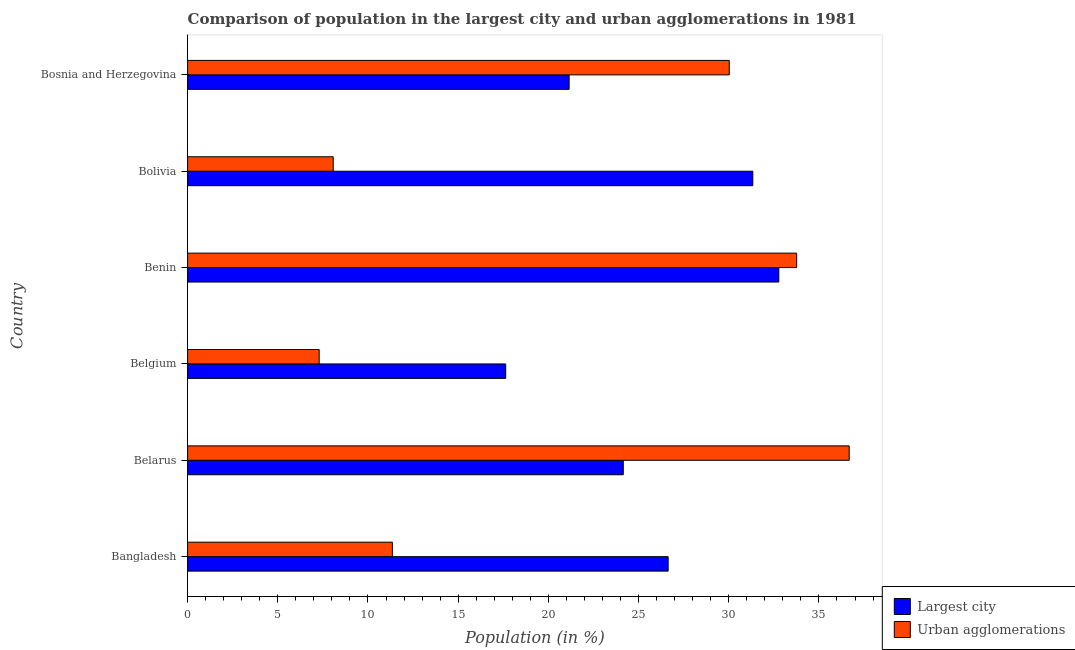How many different coloured bars are there?
Your answer should be very brief. 2. What is the label of the 1st group of bars from the top?
Your response must be concise. Bosnia and Herzegovina. What is the population in the largest city in Bosnia and Herzegovina?
Give a very brief answer. 21.15. Across all countries, what is the maximum population in the largest city?
Offer a terse response. 32.78. Across all countries, what is the minimum population in urban agglomerations?
Make the answer very short. 7.3. In which country was the population in urban agglomerations maximum?
Give a very brief answer. Belarus. In which country was the population in the largest city minimum?
Provide a short and direct response. Belgium. What is the total population in the largest city in the graph?
Ensure brevity in your answer.  153.69. What is the difference between the population in urban agglomerations in Bangladesh and that in Belgium?
Offer a terse response. 4.06. What is the difference between the population in the largest city in Bosnia and Herzegovina and the population in urban agglomerations in Belgium?
Make the answer very short. 13.86. What is the average population in urban agglomerations per country?
Offer a very short reply. 21.2. What is the difference between the highest and the second highest population in urban agglomerations?
Make the answer very short. 2.91. What is the difference between the highest and the lowest population in urban agglomerations?
Offer a very short reply. 29.38. In how many countries, is the population in the largest city greater than the average population in the largest city taken over all countries?
Keep it short and to the point. 3. Is the sum of the population in the largest city in Benin and Bolivia greater than the maximum population in urban agglomerations across all countries?
Your response must be concise. Yes. What does the 2nd bar from the top in Belarus represents?
Give a very brief answer. Largest city. What does the 2nd bar from the bottom in Benin represents?
Your answer should be compact. Urban agglomerations. Are the values on the major ticks of X-axis written in scientific E-notation?
Your answer should be very brief. No. What is the title of the graph?
Your response must be concise. Comparison of population in the largest city and urban agglomerations in 1981. Does "Electricity" appear as one of the legend labels in the graph?
Your answer should be compact. No. What is the label or title of the Y-axis?
Your answer should be very brief. Country. What is the Population (in %) in Largest city in Bangladesh?
Your answer should be very brief. 26.64. What is the Population (in %) of Urban agglomerations in Bangladesh?
Offer a terse response. 11.35. What is the Population (in %) in Largest city in Belarus?
Ensure brevity in your answer.  24.15. What is the Population (in %) in Urban agglomerations in Belarus?
Keep it short and to the point. 36.68. What is the Population (in %) in Largest city in Belgium?
Give a very brief answer. 17.63. What is the Population (in %) of Urban agglomerations in Belgium?
Make the answer very short. 7.3. What is the Population (in %) of Largest city in Benin?
Give a very brief answer. 32.78. What is the Population (in %) in Urban agglomerations in Benin?
Your answer should be compact. 33.76. What is the Population (in %) in Largest city in Bolivia?
Provide a short and direct response. 31.33. What is the Population (in %) in Urban agglomerations in Bolivia?
Provide a succinct answer. 8.07. What is the Population (in %) in Largest city in Bosnia and Herzegovina?
Your answer should be very brief. 21.15. What is the Population (in %) in Urban agglomerations in Bosnia and Herzegovina?
Your response must be concise. 30.03. Across all countries, what is the maximum Population (in %) of Largest city?
Ensure brevity in your answer.  32.78. Across all countries, what is the maximum Population (in %) in Urban agglomerations?
Offer a terse response. 36.68. Across all countries, what is the minimum Population (in %) in Largest city?
Your answer should be very brief. 17.63. Across all countries, what is the minimum Population (in %) in Urban agglomerations?
Your response must be concise. 7.3. What is the total Population (in %) in Largest city in the graph?
Your answer should be very brief. 153.69. What is the total Population (in %) in Urban agglomerations in the graph?
Your answer should be compact. 127.19. What is the difference between the Population (in %) in Largest city in Bangladesh and that in Belarus?
Provide a succinct answer. 2.49. What is the difference between the Population (in %) of Urban agglomerations in Bangladesh and that in Belarus?
Make the answer very short. -25.33. What is the difference between the Population (in %) in Largest city in Bangladesh and that in Belgium?
Your answer should be compact. 9.01. What is the difference between the Population (in %) in Urban agglomerations in Bangladesh and that in Belgium?
Your answer should be very brief. 4.06. What is the difference between the Population (in %) of Largest city in Bangladesh and that in Benin?
Offer a terse response. -6.13. What is the difference between the Population (in %) in Urban agglomerations in Bangladesh and that in Benin?
Provide a short and direct response. -22.41. What is the difference between the Population (in %) in Largest city in Bangladesh and that in Bolivia?
Your answer should be compact. -4.69. What is the difference between the Population (in %) in Urban agglomerations in Bangladesh and that in Bolivia?
Ensure brevity in your answer.  3.28. What is the difference between the Population (in %) in Largest city in Bangladesh and that in Bosnia and Herzegovina?
Ensure brevity in your answer.  5.49. What is the difference between the Population (in %) in Urban agglomerations in Bangladesh and that in Bosnia and Herzegovina?
Keep it short and to the point. -18.68. What is the difference between the Population (in %) in Largest city in Belarus and that in Belgium?
Your answer should be compact. 6.52. What is the difference between the Population (in %) in Urban agglomerations in Belarus and that in Belgium?
Your answer should be very brief. 29.38. What is the difference between the Population (in %) of Largest city in Belarus and that in Benin?
Your answer should be compact. -8.62. What is the difference between the Population (in %) in Urban agglomerations in Belarus and that in Benin?
Offer a terse response. 2.91. What is the difference between the Population (in %) of Largest city in Belarus and that in Bolivia?
Ensure brevity in your answer.  -7.18. What is the difference between the Population (in %) in Urban agglomerations in Belarus and that in Bolivia?
Offer a very short reply. 28.61. What is the difference between the Population (in %) of Largest city in Belarus and that in Bosnia and Herzegovina?
Your answer should be compact. 3. What is the difference between the Population (in %) of Urban agglomerations in Belarus and that in Bosnia and Herzegovina?
Your response must be concise. 6.65. What is the difference between the Population (in %) in Largest city in Belgium and that in Benin?
Your answer should be compact. -15.14. What is the difference between the Population (in %) of Urban agglomerations in Belgium and that in Benin?
Offer a terse response. -26.47. What is the difference between the Population (in %) of Largest city in Belgium and that in Bolivia?
Offer a terse response. -13.7. What is the difference between the Population (in %) in Urban agglomerations in Belgium and that in Bolivia?
Offer a terse response. -0.78. What is the difference between the Population (in %) of Largest city in Belgium and that in Bosnia and Herzegovina?
Make the answer very short. -3.52. What is the difference between the Population (in %) in Urban agglomerations in Belgium and that in Bosnia and Herzegovina?
Your answer should be very brief. -22.73. What is the difference between the Population (in %) in Largest city in Benin and that in Bolivia?
Make the answer very short. 1.44. What is the difference between the Population (in %) of Urban agglomerations in Benin and that in Bolivia?
Your answer should be very brief. 25.69. What is the difference between the Population (in %) in Largest city in Benin and that in Bosnia and Herzegovina?
Provide a succinct answer. 11.62. What is the difference between the Population (in %) of Urban agglomerations in Benin and that in Bosnia and Herzegovina?
Offer a terse response. 3.74. What is the difference between the Population (in %) in Largest city in Bolivia and that in Bosnia and Herzegovina?
Give a very brief answer. 10.18. What is the difference between the Population (in %) in Urban agglomerations in Bolivia and that in Bosnia and Herzegovina?
Provide a succinct answer. -21.96. What is the difference between the Population (in %) in Largest city in Bangladesh and the Population (in %) in Urban agglomerations in Belarus?
Offer a very short reply. -10.04. What is the difference between the Population (in %) in Largest city in Bangladesh and the Population (in %) in Urban agglomerations in Belgium?
Keep it short and to the point. 19.35. What is the difference between the Population (in %) of Largest city in Bangladesh and the Population (in %) of Urban agglomerations in Benin?
Your answer should be compact. -7.12. What is the difference between the Population (in %) of Largest city in Bangladesh and the Population (in %) of Urban agglomerations in Bolivia?
Give a very brief answer. 18.57. What is the difference between the Population (in %) in Largest city in Bangladesh and the Population (in %) in Urban agglomerations in Bosnia and Herzegovina?
Offer a very short reply. -3.39. What is the difference between the Population (in %) of Largest city in Belarus and the Population (in %) of Urban agglomerations in Belgium?
Your answer should be compact. 16.86. What is the difference between the Population (in %) in Largest city in Belarus and the Population (in %) in Urban agglomerations in Benin?
Keep it short and to the point. -9.61. What is the difference between the Population (in %) of Largest city in Belarus and the Population (in %) of Urban agglomerations in Bolivia?
Make the answer very short. 16.08. What is the difference between the Population (in %) in Largest city in Belarus and the Population (in %) in Urban agglomerations in Bosnia and Herzegovina?
Provide a succinct answer. -5.88. What is the difference between the Population (in %) in Largest city in Belgium and the Population (in %) in Urban agglomerations in Benin?
Give a very brief answer. -16.13. What is the difference between the Population (in %) of Largest city in Belgium and the Population (in %) of Urban agglomerations in Bolivia?
Keep it short and to the point. 9.56. What is the difference between the Population (in %) of Largest city in Belgium and the Population (in %) of Urban agglomerations in Bosnia and Herzegovina?
Make the answer very short. -12.39. What is the difference between the Population (in %) in Largest city in Benin and the Population (in %) in Urban agglomerations in Bolivia?
Your answer should be compact. 24.7. What is the difference between the Population (in %) in Largest city in Benin and the Population (in %) in Urban agglomerations in Bosnia and Herzegovina?
Give a very brief answer. 2.75. What is the difference between the Population (in %) in Largest city in Bolivia and the Population (in %) in Urban agglomerations in Bosnia and Herzegovina?
Your answer should be very brief. 1.31. What is the average Population (in %) of Largest city per country?
Your answer should be very brief. 25.61. What is the average Population (in %) in Urban agglomerations per country?
Make the answer very short. 21.2. What is the difference between the Population (in %) in Largest city and Population (in %) in Urban agglomerations in Bangladesh?
Your answer should be compact. 15.29. What is the difference between the Population (in %) in Largest city and Population (in %) in Urban agglomerations in Belarus?
Your answer should be compact. -12.53. What is the difference between the Population (in %) of Largest city and Population (in %) of Urban agglomerations in Belgium?
Provide a succinct answer. 10.34. What is the difference between the Population (in %) in Largest city and Population (in %) in Urban agglomerations in Benin?
Offer a very short reply. -0.99. What is the difference between the Population (in %) in Largest city and Population (in %) in Urban agglomerations in Bolivia?
Offer a very short reply. 23.26. What is the difference between the Population (in %) in Largest city and Population (in %) in Urban agglomerations in Bosnia and Herzegovina?
Keep it short and to the point. -8.88. What is the ratio of the Population (in %) in Largest city in Bangladesh to that in Belarus?
Provide a short and direct response. 1.1. What is the ratio of the Population (in %) of Urban agglomerations in Bangladesh to that in Belarus?
Your answer should be very brief. 0.31. What is the ratio of the Population (in %) in Largest city in Bangladesh to that in Belgium?
Your answer should be very brief. 1.51. What is the ratio of the Population (in %) of Urban agglomerations in Bangladesh to that in Belgium?
Your answer should be very brief. 1.56. What is the ratio of the Population (in %) of Largest city in Bangladesh to that in Benin?
Give a very brief answer. 0.81. What is the ratio of the Population (in %) in Urban agglomerations in Bangladesh to that in Benin?
Your answer should be compact. 0.34. What is the ratio of the Population (in %) in Largest city in Bangladesh to that in Bolivia?
Provide a succinct answer. 0.85. What is the ratio of the Population (in %) of Urban agglomerations in Bangladesh to that in Bolivia?
Your response must be concise. 1.41. What is the ratio of the Population (in %) in Largest city in Bangladesh to that in Bosnia and Herzegovina?
Make the answer very short. 1.26. What is the ratio of the Population (in %) of Urban agglomerations in Bangladesh to that in Bosnia and Herzegovina?
Provide a short and direct response. 0.38. What is the ratio of the Population (in %) of Largest city in Belarus to that in Belgium?
Make the answer very short. 1.37. What is the ratio of the Population (in %) of Urban agglomerations in Belarus to that in Belgium?
Ensure brevity in your answer.  5.03. What is the ratio of the Population (in %) of Largest city in Belarus to that in Benin?
Ensure brevity in your answer.  0.74. What is the ratio of the Population (in %) in Urban agglomerations in Belarus to that in Benin?
Provide a succinct answer. 1.09. What is the ratio of the Population (in %) of Largest city in Belarus to that in Bolivia?
Offer a terse response. 0.77. What is the ratio of the Population (in %) in Urban agglomerations in Belarus to that in Bolivia?
Provide a succinct answer. 4.54. What is the ratio of the Population (in %) of Largest city in Belarus to that in Bosnia and Herzegovina?
Give a very brief answer. 1.14. What is the ratio of the Population (in %) of Urban agglomerations in Belarus to that in Bosnia and Herzegovina?
Offer a very short reply. 1.22. What is the ratio of the Population (in %) in Largest city in Belgium to that in Benin?
Ensure brevity in your answer.  0.54. What is the ratio of the Population (in %) in Urban agglomerations in Belgium to that in Benin?
Keep it short and to the point. 0.22. What is the ratio of the Population (in %) of Largest city in Belgium to that in Bolivia?
Provide a succinct answer. 0.56. What is the ratio of the Population (in %) in Urban agglomerations in Belgium to that in Bolivia?
Provide a succinct answer. 0.9. What is the ratio of the Population (in %) in Largest city in Belgium to that in Bosnia and Herzegovina?
Offer a very short reply. 0.83. What is the ratio of the Population (in %) of Urban agglomerations in Belgium to that in Bosnia and Herzegovina?
Your answer should be very brief. 0.24. What is the ratio of the Population (in %) in Largest city in Benin to that in Bolivia?
Your response must be concise. 1.05. What is the ratio of the Population (in %) of Urban agglomerations in Benin to that in Bolivia?
Offer a very short reply. 4.18. What is the ratio of the Population (in %) of Largest city in Benin to that in Bosnia and Herzegovina?
Your answer should be compact. 1.55. What is the ratio of the Population (in %) of Urban agglomerations in Benin to that in Bosnia and Herzegovina?
Offer a very short reply. 1.12. What is the ratio of the Population (in %) in Largest city in Bolivia to that in Bosnia and Herzegovina?
Make the answer very short. 1.48. What is the ratio of the Population (in %) in Urban agglomerations in Bolivia to that in Bosnia and Herzegovina?
Make the answer very short. 0.27. What is the difference between the highest and the second highest Population (in %) in Largest city?
Ensure brevity in your answer.  1.44. What is the difference between the highest and the second highest Population (in %) of Urban agglomerations?
Provide a succinct answer. 2.91. What is the difference between the highest and the lowest Population (in %) in Largest city?
Provide a succinct answer. 15.14. What is the difference between the highest and the lowest Population (in %) in Urban agglomerations?
Make the answer very short. 29.38. 